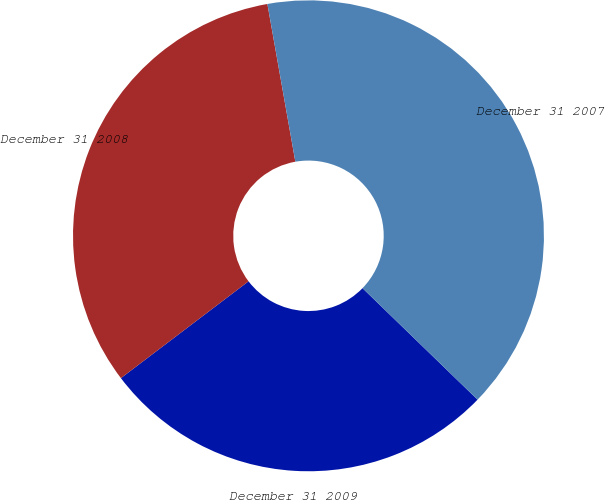<chart> <loc_0><loc_0><loc_500><loc_500><pie_chart><fcel>December 31 2009<fcel>December 31 2008<fcel>December 31 2007<nl><fcel>27.42%<fcel>32.54%<fcel>40.04%<nl></chart> 